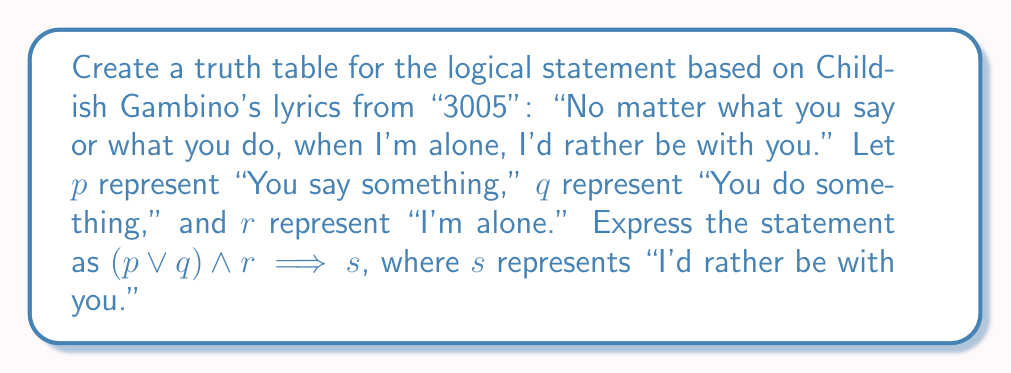What is the answer to this math problem? Let's break this down step-by-step:

1) First, we need to identify the number of variables: $p$, $q$, $r$, and $s$. With 4 variables, our truth table will have $2^4 = 16$ rows.

2) We'll start by listing all possible combinations of truth values for $p$, $q$, $r$, and $s$.

3) Next, we'll evaluate $(p \lor q)$. This is true when either $p$ or $q$ (or both) are true.

4) Then, we'll evaluate $(p \lor q) \land r$. This is true when both $(p \lor q)$ and $r$ are true.

5) Finally, we'll evaluate the implication $(p \lor q) \land r \implies s$. Remember, an implication is false only when the antecedent is true and the consequent is false.

Here's the truth table:

$$
\begin{array}{|c|c|c|c|c|c|c|}
\hline
p & q & r & s & p \lor q & (p \lor q) \land r & (p \lor q) \land r \implies s \\
\hline
0 & 0 & 0 & 0 & 0 & 0 & 1 \\
0 & 0 & 0 & 1 & 0 & 0 & 1 \\
0 & 0 & 1 & 0 & 0 & 0 & 1 \\
0 & 0 & 1 & 1 & 0 & 0 & 1 \\
0 & 1 & 0 & 0 & 1 & 0 & 1 \\
0 & 1 & 0 & 1 & 1 & 0 & 1 \\
0 & 1 & 1 & 0 & 1 & 1 & 0 \\
0 & 1 & 1 & 1 & 1 & 1 & 1 \\
1 & 0 & 0 & 0 & 1 & 0 & 1 \\
1 & 0 & 0 & 1 & 1 & 0 & 1 \\
1 & 0 & 1 & 0 & 1 & 1 & 0 \\
1 & 0 & 1 & 1 & 1 & 1 & 1 \\
1 & 1 & 0 & 0 & 1 & 0 & 1 \\
1 & 1 & 0 & 1 & 1 & 0 & 1 \\
1 & 1 & 1 & 0 & 1 & 1 & 0 \\
1 & 1 & 1 & 1 & 1 & 1 & 1 \\
\hline
\end{array}
$$

The statement is false only when $(p \lor q) \land r$ is true (i.e., something is said or done and I'm alone) but $s$ is false (i.e., I don't prefer to be with you). This occurs in rows 7, 11, and 15 of the truth table.
Answer: The truth table has 16 rows, with the statement being true in 13 rows and false in 3 rows. 